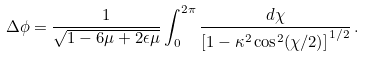Convert formula to latex. <formula><loc_0><loc_0><loc_500><loc_500>\Delta \phi = \frac { 1 } { \sqrt { 1 - 6 \mu + 2 \epsilon \mu } } \int _ { 0 } ^ { 2 \pi } \frac { d \chi } { \left [ 1 - \kappa ^ { 2 } \cos ^ { 2 } ( \chi / 2 ) \right ] ^ { 1 / 2 } } \, .</formula> 